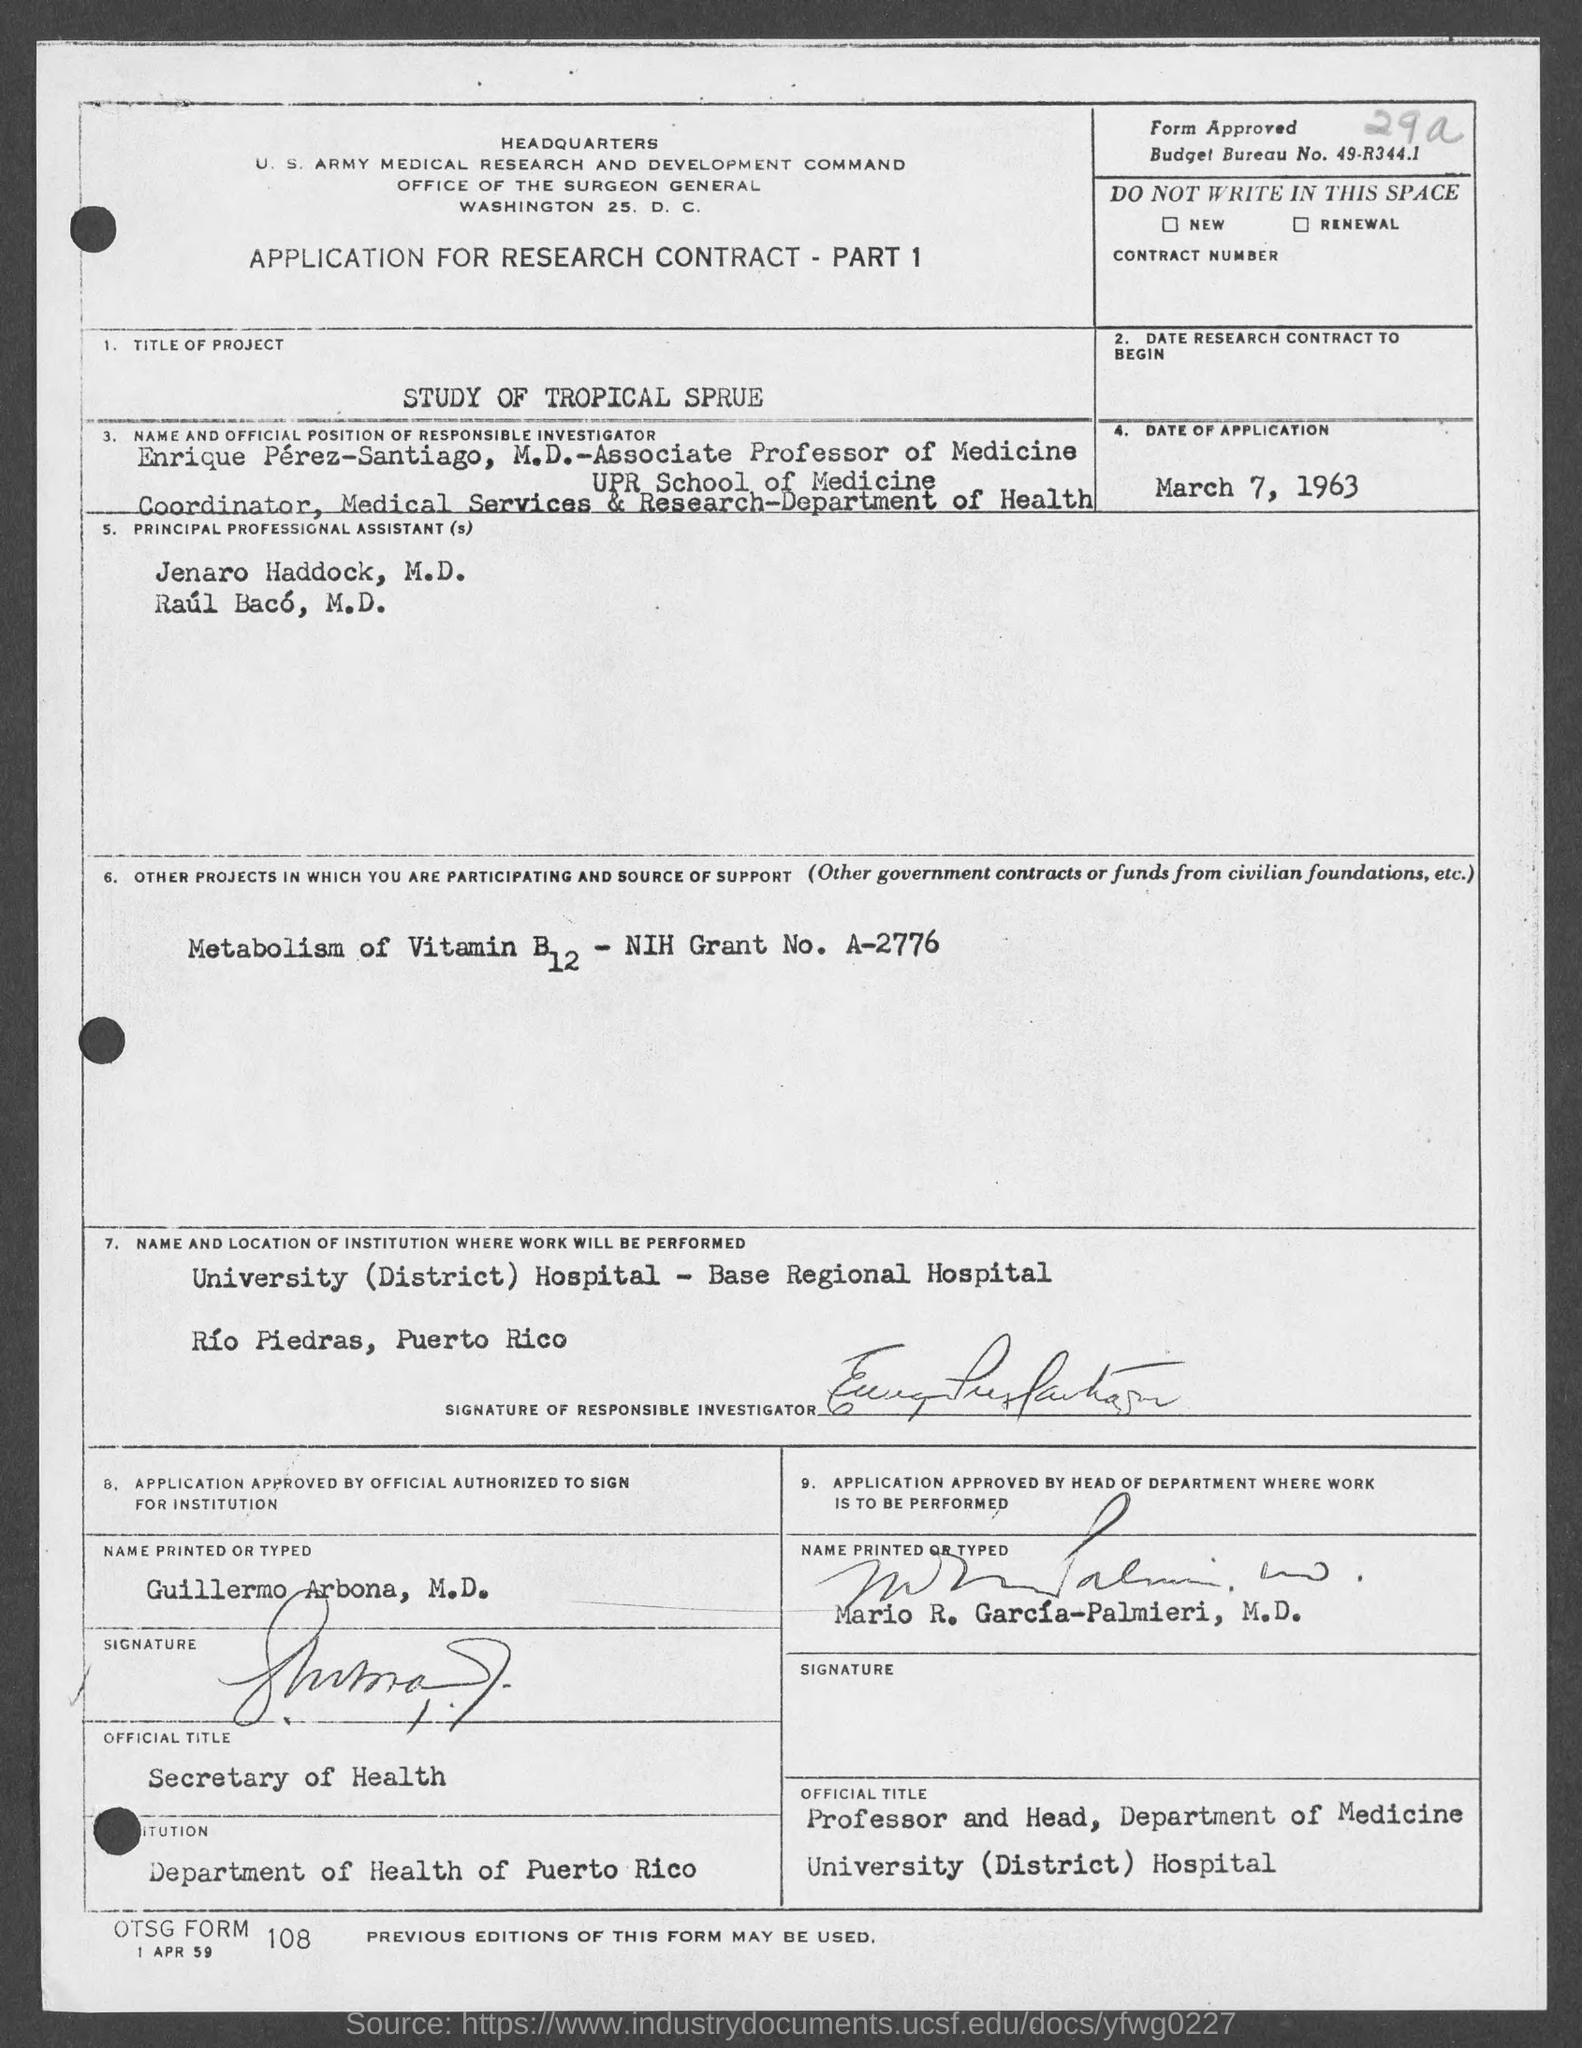What is the budget bureau no.?
Provide a short and direct response. 49-R344.1. What is the title of project?
Offer a terse response. Study of tropical sprue. What is the official title of guillermo arbona, m.d.?
Make the answer very short. Secretary of Health. 